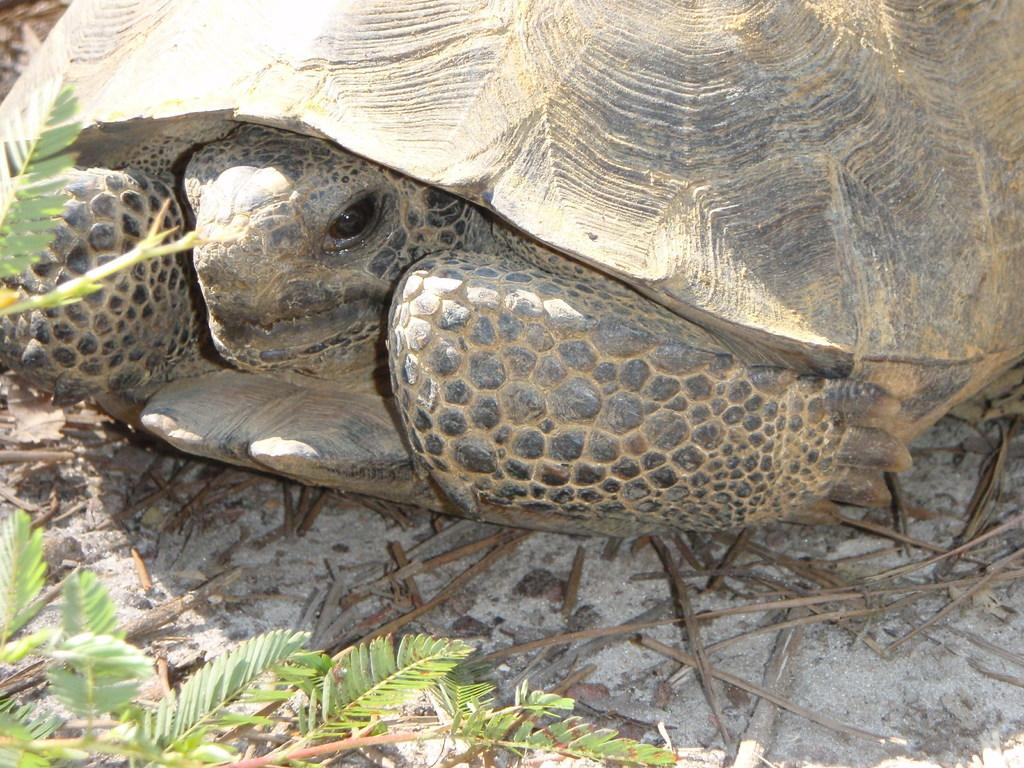What animal is on the ground in the image? There is a tortoise on the ground in the image. What else can be seen in the image besides the tortoise? There are plants in the image. What advice does the tortoise give to the aunt in the image? There is no aunt present in the image, and the tortoise does not communicate or give advice. 